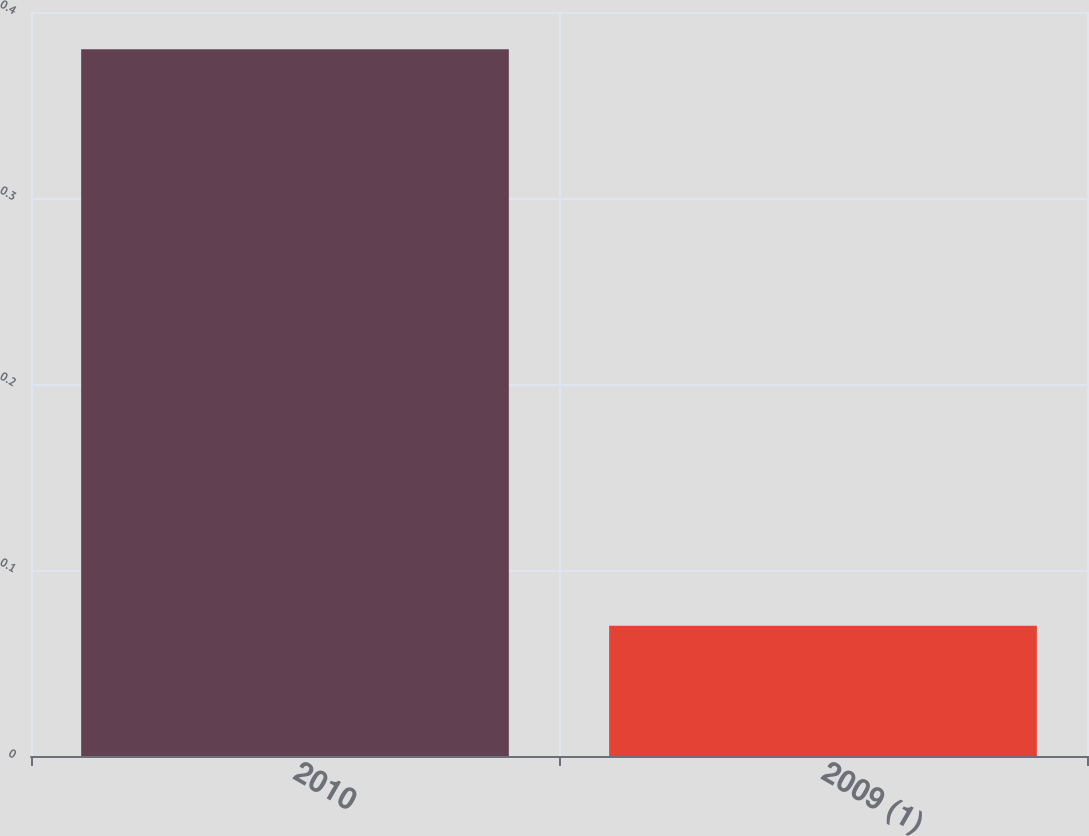<chart> <loc_0><loc_0><loc_500><loc_500><bar_chart><fcel>2010<fcel>2009 (1)<nl><fcel>0.38<fcel>0.07<nl></chart> 